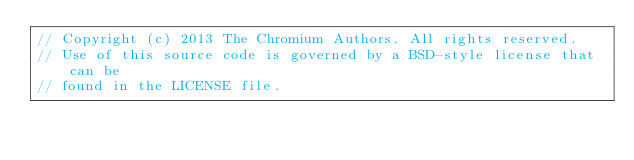<code> <loc_0><loc_0><loc_500><loc_500><_C++_>// Copyright (c) 2013 The Chromium Authors. All rights reserved.
// Use of this source code is governed by a BSD-style license that can be
// found in the LICENSE file.
</code> 